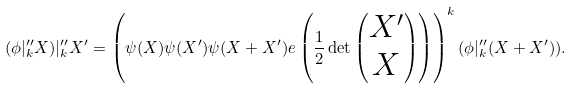Convert formula to latex. <formula><loc_0><loc_0><loc_500><loc_500>( \phi | ^ { \prime \prime } _ { k } X ) | ^ { \prime \prime } _ { k } X ^ { \prime } = \left ( \psi ( X ) \psi ( X ^ { \prime } ) \psi ( X + X ^ { \prime } ) e \left ( \frac { 1 } { 2 } \det \begin{pmatrix} X ^ { \prime } \\ X \end{pmatrix} \right ) \right ) ^ { k } ( \phi | ^ { \prime \prime } _ { k } ( X + X ^ { \prime } ) ) .</formula> 